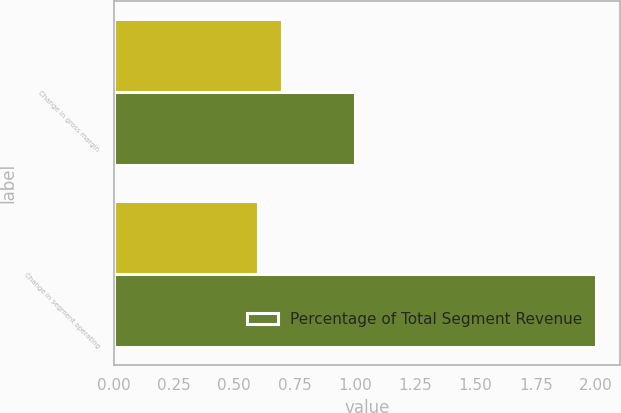Convert chart. <chart><loc_0><loc_0><loc_500><loc_500><stacked_bar_chart><ecel><fcel>Change in gross margin<fcel>Change in segment operating<nl><fcel>nan<fcel>0.7<fcel>0.6<nl><fcel>Percentage of Total Segment Revenue<fcel>1<fcel>2<nl></chart> 